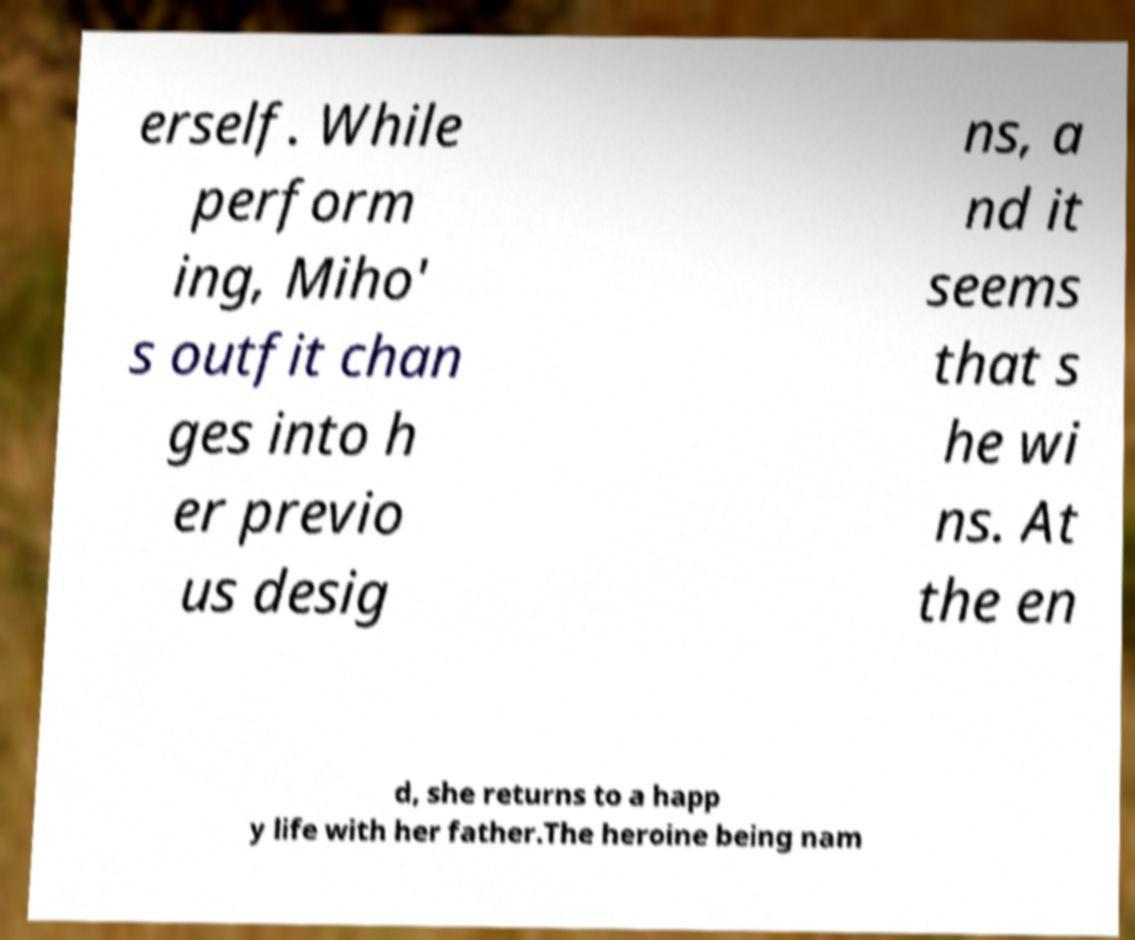Can you read and provide the text displayed in the image?This photo seems to have some interesting text. Can you extract and type it out for me? erself. While perform ing, Miho' s outfit chan ges into h er previo us desig ns, a nd it seems that s he wi ns. At the en d, she returns to a happ y life with her father.The heroine being nam 